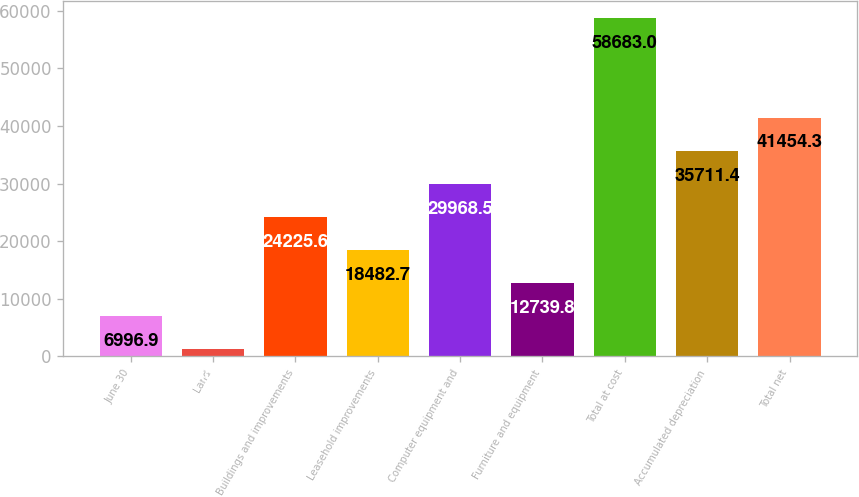<chart> <loc_0><loc_0><loc_500><loc_500><bar_chart><fcel>June 30<fcel>Land<fcel>Buildings and improvements<fcel>Leasehold improvements<fcel>Computer equipment and<fcel>Furniture and equipment<fcel>Total at cost<fcel>Accumulated depreciation<fcel>Total net<nl><fcel>6996.9<fcel>1254<fcel>24225.6<fcel>18482.7<fcel>29968.5<fcel>12739.8<fcel>58683<fcel>35711.4<fcel>41454.3<nl></chart> 